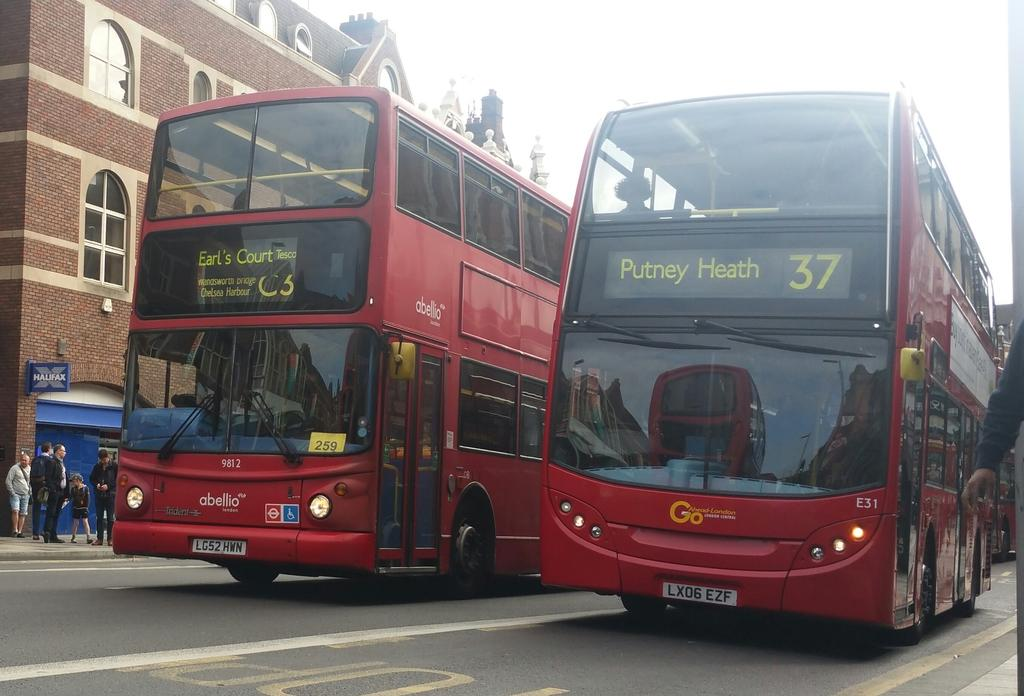How many red buses can be seen on the road in the image? There are 2 red buses on the road in the image. What can be seen on the left side of the road? There are people standing on the left side of the road. What type of structure is present in the image? There is a building in the image. How do the buses maintain their balance on the road in the image? The buses maintain their balance on the road through their suspension systems and the stability provided by their tires. However, the image does not specifically show the buses in motion or provide information about their balance. --- 